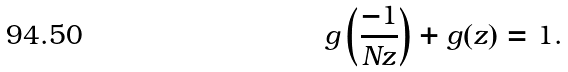<formula> <loc_0><loc_0><loc_500><loc_500>g \left ( \frac { - 1 } { N z } \right ) + g ( z ) = 1 .</formula> 